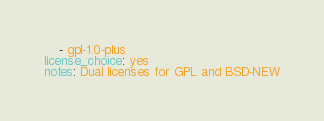Convert code to text. <code><loc_0><loc_0><loc_500><loc_500><_YAML_>    - gpl-1.0-plus
license_choice: yes
notes: Dual licenses for GPL and BSD-NEW
</code> 